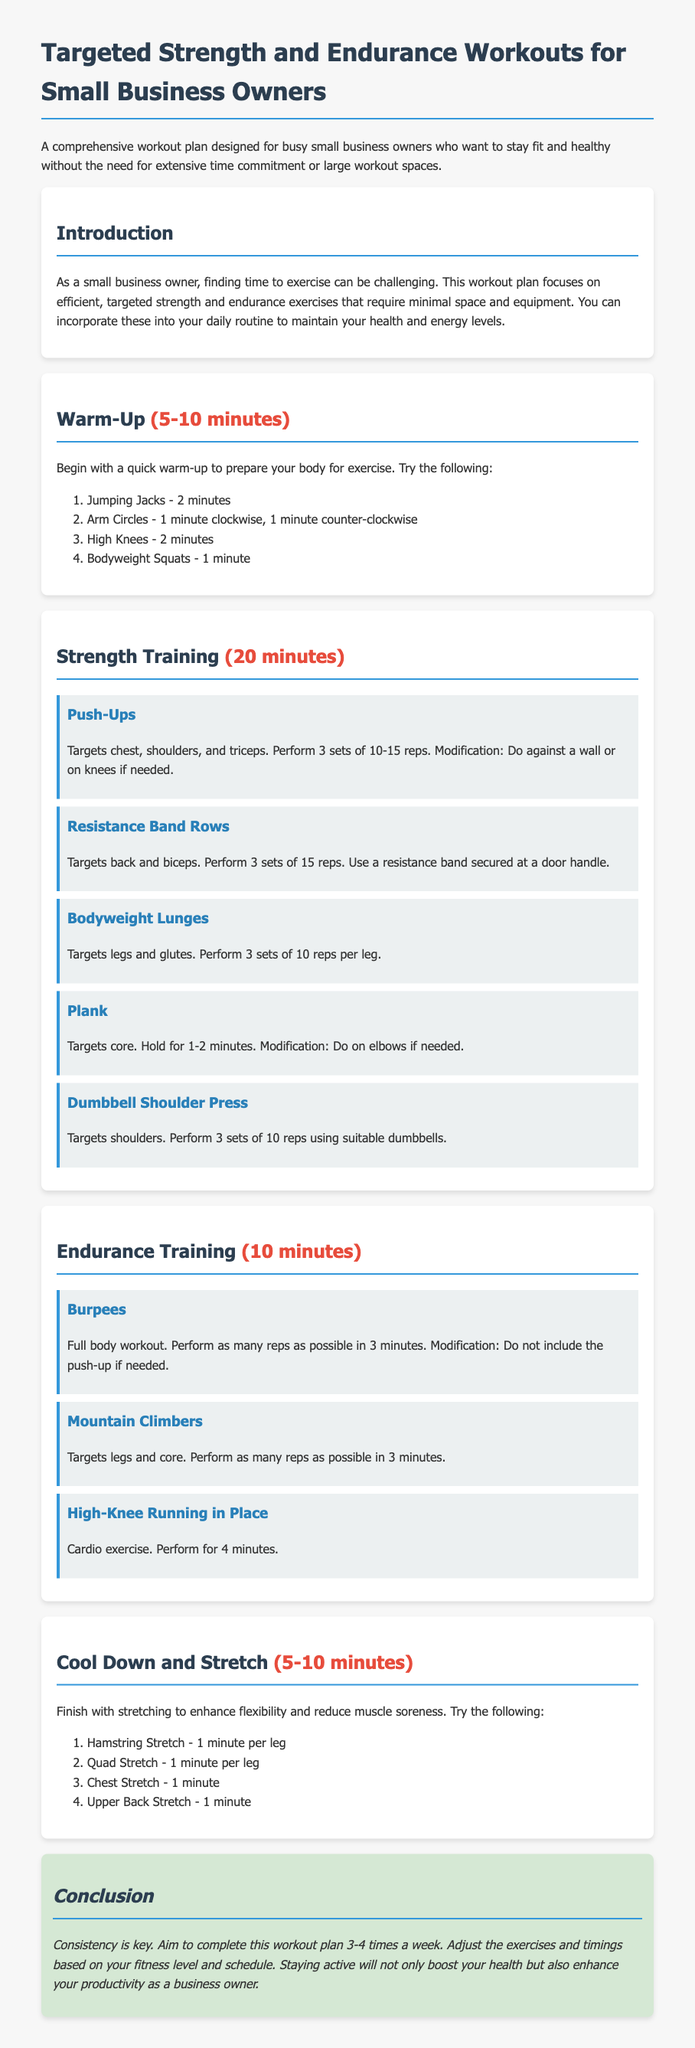What are the key focuses of this workout plan? The key focuses are efficient, targeted strength and endurance exercises that require minimal space and equipment.
Answer: efficient, targeted strength and endurance exercises How long should the warm-up last? The warm-up should last between 5 to 10 minutes according to the document.
Answer: 5-10 minutes How many workouts per week are recommended? The document recommends completing this workout plan 3-4 times a week for consistency.
Answer: 3-4 times a week What is the first exercise listed in the strength training section? The first exercise listed is Push-Ups, targeting the chest, shoulders, and triceps.
Answer: Push-Ups What is the total time allocated for strength training? The document specifies that the strength training section lasts for 20 minutes.
Answer: 20 minutes What kind of equipment is needed for Resistance Band Rows? The exercise requires a resistance band secured at a door handle.
Answer: resistance band How long should you hold the Plank exercise? The Plank exercise should be held for 1-2 minutes as stated in the document.
Answer: 1-2 minutes Which exercise should be performed as many reps as possible in 3 minutes? Burpees should be performed as many reps as possible in 3 minutes according to the workout plan.
Answer: Burpees What is the purpose of the cool down and stretch section? The purpose is to enhance flexibility and reduce muscle soreness.
Answer: enhance flexibility and reduce muscle soreness 